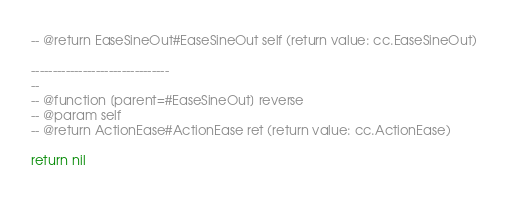Convert code to text. <code><loc_0><loc_0><loc_500><loc_500><_Lua_>-- @return EaseSineOut#EaseSineOut self (return value: cc.EaseSineOut)
        
--------------------------------
-- 
-- @function [parent=#EaseSineOut] reverse 
-- @param self
-- @return ActionEase#ActionEase ret (return value: cc.ActionEase)
        
return nil
</code> 